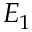<formula> <loc_0><loc_0><loc_500><loc_500>E _ { 1 }</formula> 